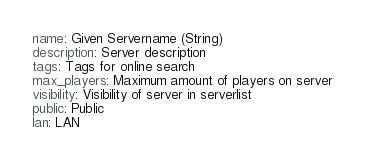Convert code to text. <code><loc_0><loc_0><loc_500><loc_500><_YAML_>name: Given Servername (String)
description: Server description
tags: Tags for online search
max_players: Maximum amount of players on server
visibility: Visibility of server in serverlist
public: Public
lan: LAN</code> 